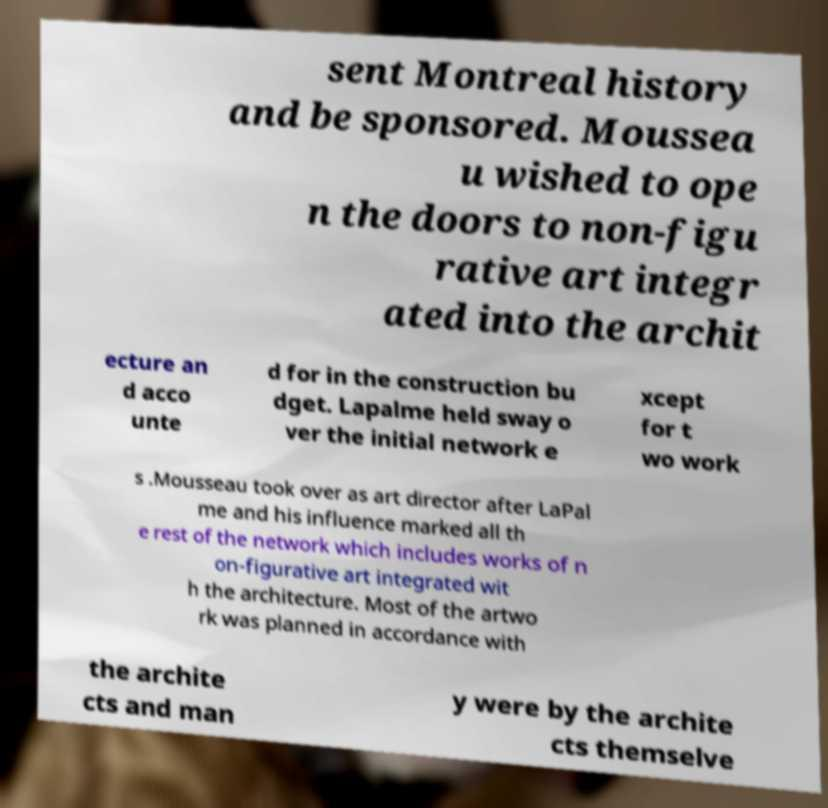Can you read and provide the text displayed in the image?This photo seems to have some interesting text. Can you extract and type it out for me? sent Montreal history and be sponsored. Moussea u wished to ope n the doors to non-figu rative art integr ated into the archit ecture an d acco unte d for in the construction bu dget. Lapalme held sway o ver the initial network e xcept for t wo work s .Mousseau took over as art director after LaPal me and his influence marked all th e rest of the network which includes works of n on-figurative art integrated wit h the architecture. Most of the artwo rk was planned in accordance with the archite cts and man y were by the archite cts themselve 